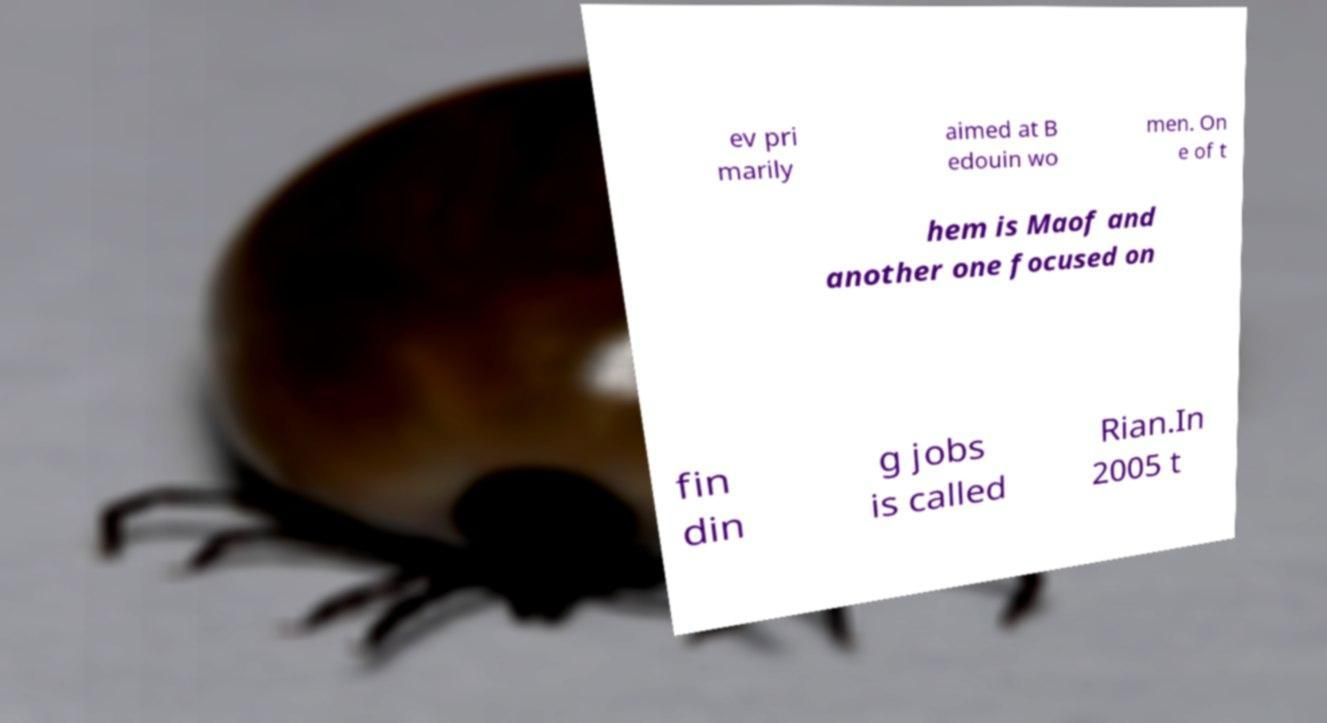Can you read and provide the text displayed in the image?This photo seems to have some interesting text. Can you extract and type it out for me? ev pri marily aimed at B edouin wo men. On e of t hem is Maof and another one focused on fin din g jobs is called Rian.In 2005 t 